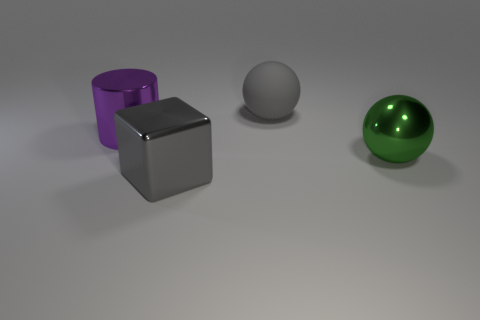Add 1 tiny purple shiny objects. How many objects exist? 5 Subtract 1 blocks. How many blocks are left? 0 Subtract all green spheres. How many spheres are left? 1 Add 4 large purple matte cylinders. How many large purple matte cylinders exist? 4 Subtract 0 brown cubes. How many objects are left? 4 Subtract all cubes. How many objects are left? 3 Subtract all blue balls. Subtract all cyan cylinders. How many balls are left? 2 Subtract all gray cubes. How many blue cylinders are left? 0 Subtract all yellow metallic cylinders. Subtract all big green metal objects. How many objects are left? 3 Add 4 matte things. How many matte things are left? 5 